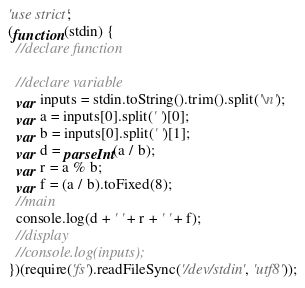<code> <loc_0><loc_0><loc_500><loc_500><_JavaScript_>'use strict';
(function(stdin) {
  //declare function

  //declare variable
  var inputs = stdin.toString().trim().split('\n');
  var a = inputs[0].split(' ')[0];
  var b = inputs[0].split(' ')[1];
  var d = parseInt(a / b);
  var r = a % b;
  var f = (a / b).toFixed(8);
  //main
  console.log(d + ' ' + r + ' ' + f);
  //display
  //console.log(inputs);
})(require('fs').readFileSync('/dev/stdin', 'utf8'));</code> 